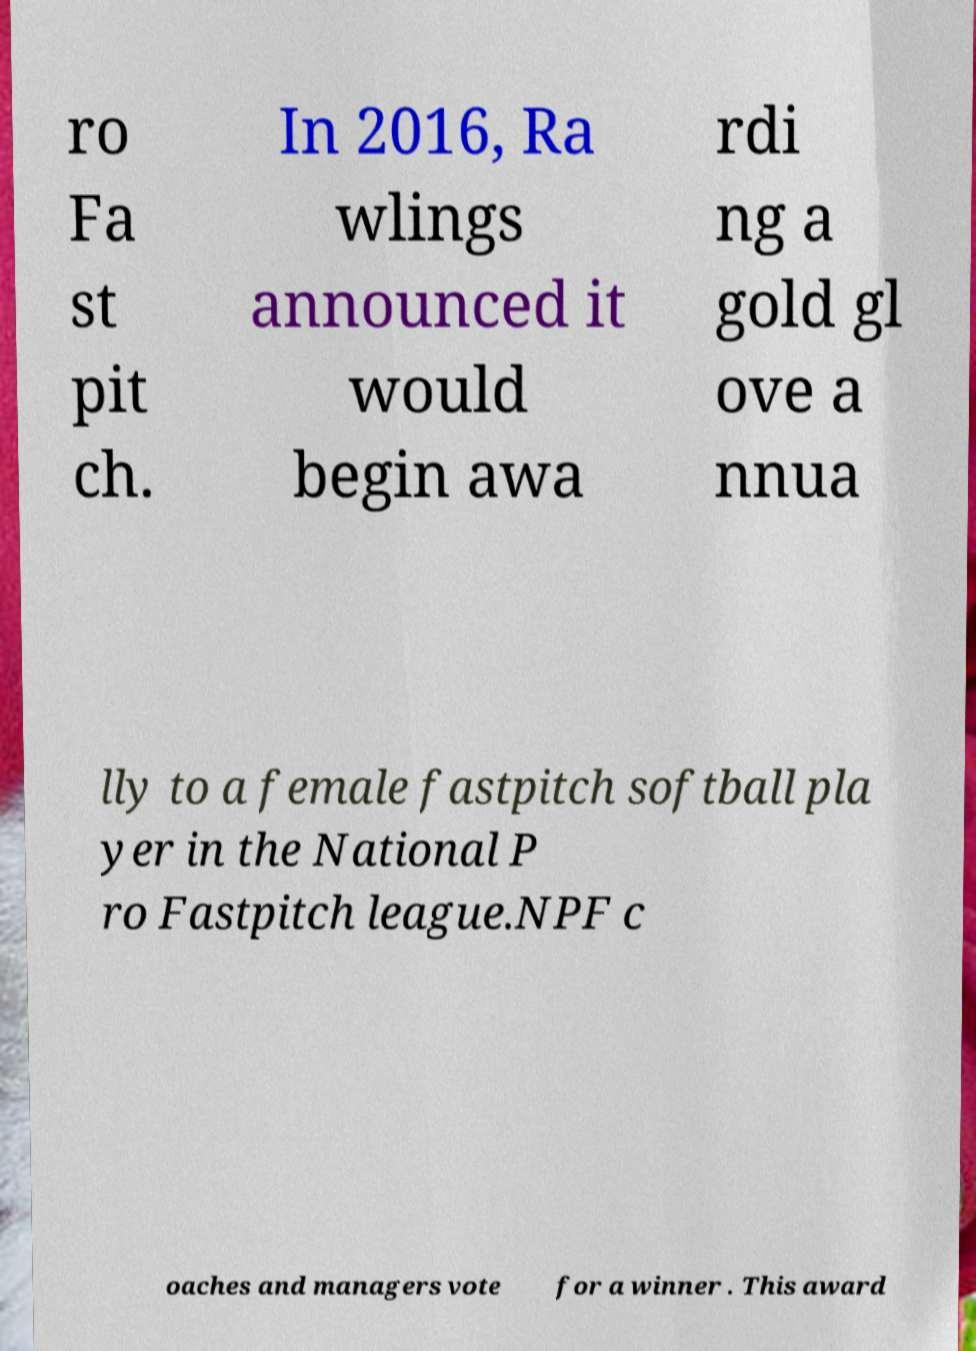There's text embedded in this image that I need extracted. Can you transcribe it verbatim? ro Fa st pit ch. In 2016, Ra wlings announced it would begin awa rdi ng a gold gl ove a nnua lly to a female fastpitch softball pla yer in the National P ro Fastpitch league.NPF c oaches and managers vote for a winner . This award 